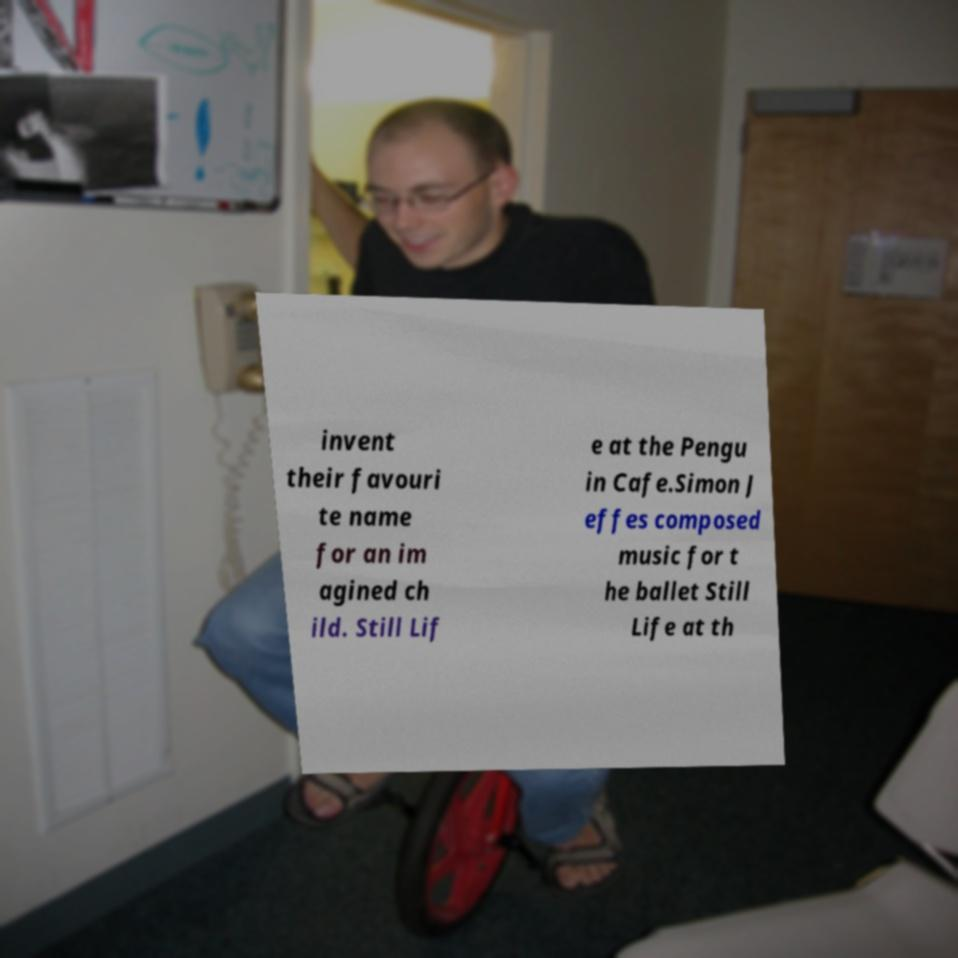Could you assist in decoding the text presented in this image and type it out clearly? invent their favouri te name for an im agined ch ild. Still Lif e at the Pengu in Cafe.Simon J effes composed music for t he ballet Still Life at th 